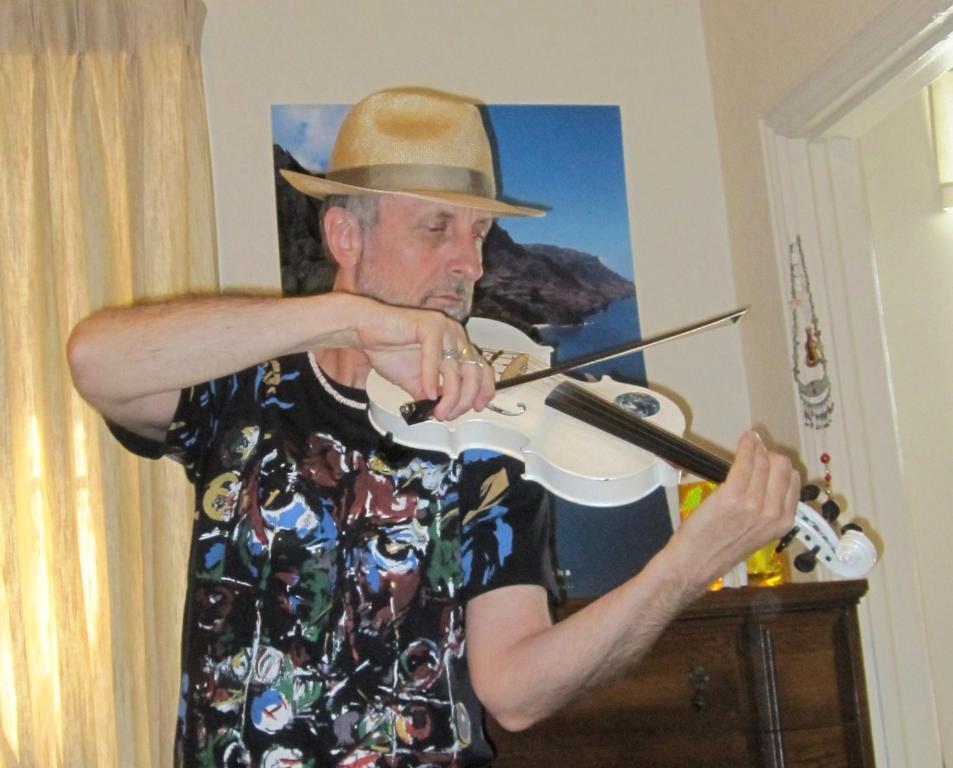In one or two sentences, can you explain what this image depicts? In the center of the image we can see a man is standing and wearing T-shirt, cap and playing a guitar. In the background of the image we can see a curtain, door, rack and board on the wall. On the rack, we can see the bottles. 